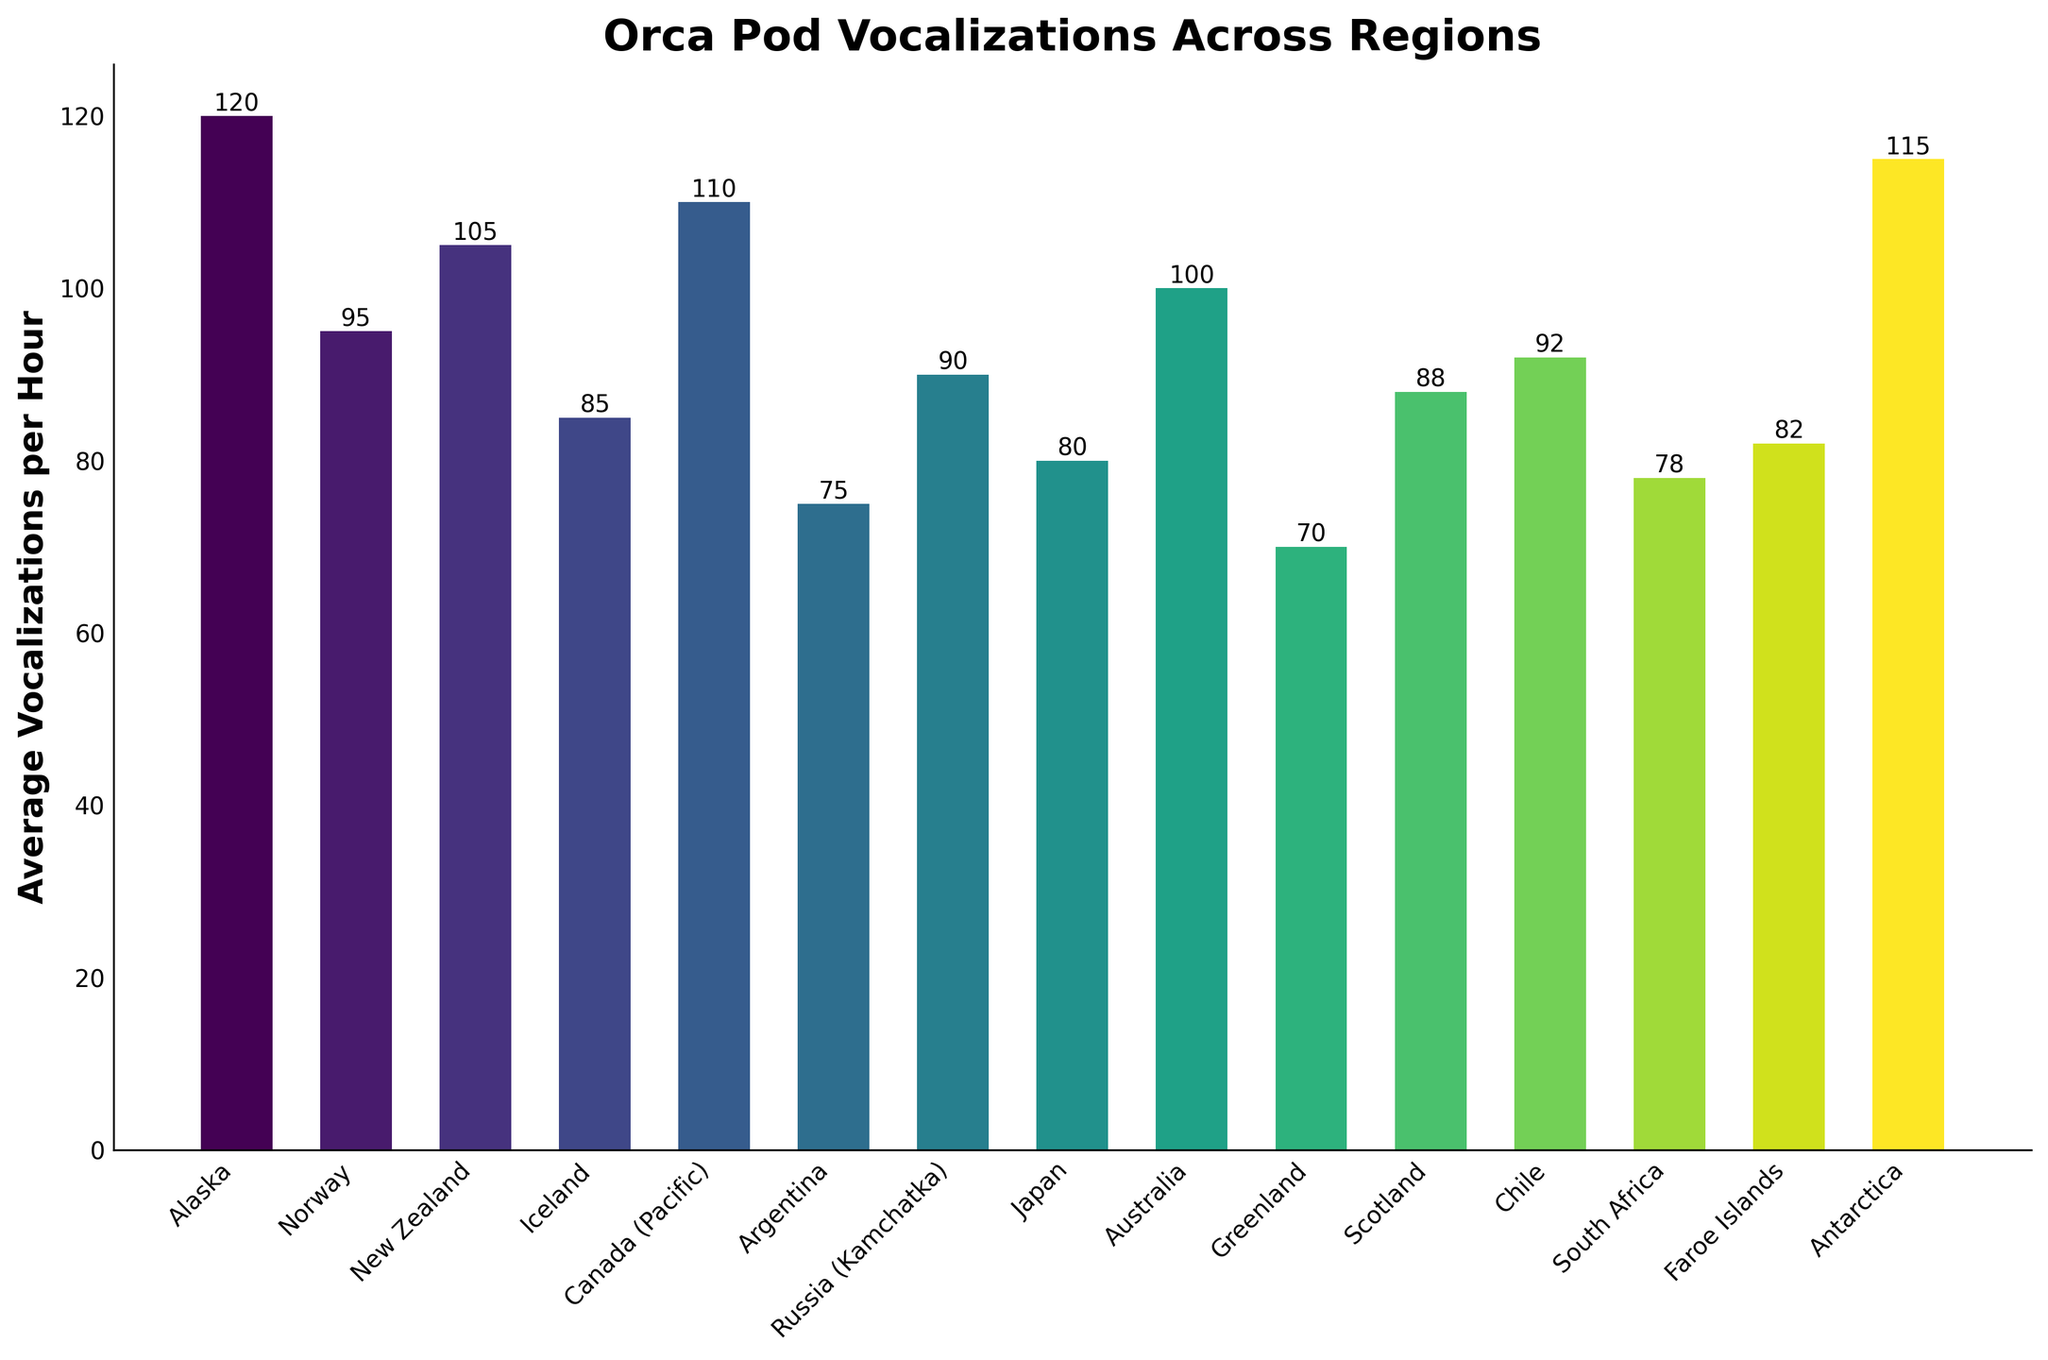Which region has the highest average vocalizations per hour? By examining the heights of the bars, we see that the tallest bar represents the region with the highest average vocalizations per hour. The tallest bar belongs to Alaska.
Answer: Alaska Which region has fewer average vocalizations per hour, Japan or South Africa? By comparing the heights of the bars for Japan and South Africa, we can see that the Japan bar is slightly higher than the South Africa bar, indicating that South Africa has fewer average vocalizations per hour.
Answer: South Africa What is the difference in average vocalizations per hour between Antarctica and Greenland? To find the difference, we look at the heights of the bars for Antarctica (115) and Greenland (70), then subtract the smaller value from the larger value: 115 - 70 = 45.
Answer: 45 Which three regions have the lowest average vocalizations per hour? By identifying the three shortest bars, we find that the three regions with the lowest average vocalizations per hour are Greenland (70), Argentina (75), and South Africa (78).
Answer: Greenland, Argentina, South Africa What is the average vocalizations per hour across Canada (Pacific), Iceland, and Chile? To calculate the average, we sum the values for Canada (Pacific) (110), Iceland (85), and Chile (92), and then divide by 3: (110 + 85 + 92) / 3 = 287 / 3 ≈ 95.67.
Answer: 95.67 How many regions have an average vocalization rate higher than 100 per hour? By visually scanning the bars, we count the regions with bars higher than 100. These regions are Alaska (120), Antarctica (115), Canada (Pacific) (110), New Zealand (105), and Australia (100). So, 5 regions have rates higher than 100.
Answer: 5 Which region has an average vocalizations rate closest to 90 per hour? By examining the bar heights, we see that the region closest to 90 is Russia (Kamchatka), which has an average of 90 vocalizations per hour.
Answer: Russia (Kamchatka) Rank the top three regions in descending order by average vocalizations per hour. By identifying and ordering the tallest three bars, we find that they are Alaska (120), Antarctica (115), and Canada (Pacific) (110).
Answer: Alaska, Antarctica, Canada (Pacific) Is the average vocalizations per hour in Norway greater than or less than that in New Zealand? By comparing the heights of the bars for Norway (95) and New Zealand (105), we see that the New Zealand bar is taller, indicating that Norway has fewer average vocalizations per hour.
Answer: Less What’s the total average vocalizations per hour for regions in the Southern Hemisphere (New Zealand, Argentina, Australia, Antarctica, South Africa, Chile)? Sum the average vocalizations for New Zealand (105), Argentina (75), Australia (100), Antarctica (115), South Africa (78), Chile (92): 105 + 75 + 100 + 115 + 78 + 92 = 565.
Answer: 565 